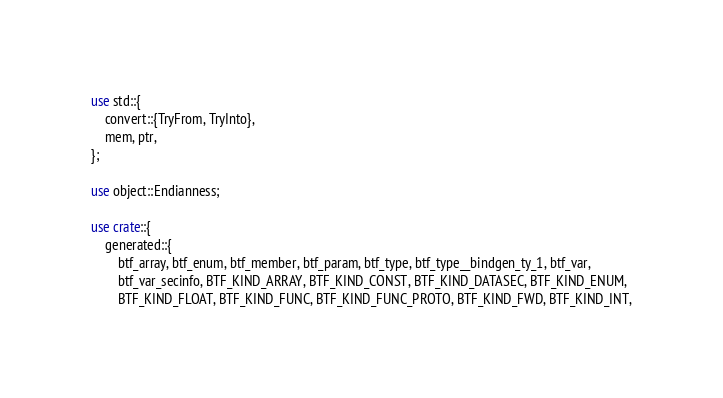Convert code to text. <code><loc_0><loc_0><loc_500><loc_500><_Rust_>use std::{
    convert::{TryFrom, TryInto},
    mem, ptr,
};

use object::Endianness;

use crate::{
    generated::{
        btf_array, btf_enum, btf_member, btf_param, btf_type, btf_type__bindgen_ty_1, btf_var,
        btf_var_secinfo, BTF_KIND_ARRAY, BTF_KIND_CONST, BTF_KIND_DATASEC, BTF_KIND_ENUM,
        BTF_KIND_FLOAT, BTF_KIND_FUNC, BTF_KIND_FUNC_PROTO, BTF_KIND_FWD, BTF_KIND_INT,</code> 